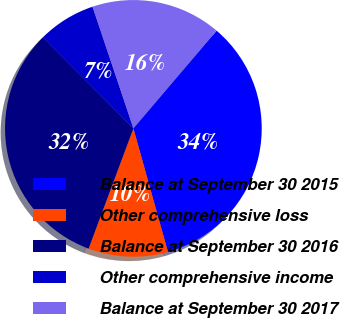<chart> <loc_0><loc_0><loc_500><loc_500><pie_chart><fcel>Balance at September 30 2015<fcel>Other comprehensive loss<fcel>Balance at September 30 2016<fcel>Other comprehensive income<fcel>Balance at September 30 2017<nl><fcel>34.43%<fcel>10.02%<fcel>31.88%<fcel>7.29%<fcel>16.39%<nl></chart> 